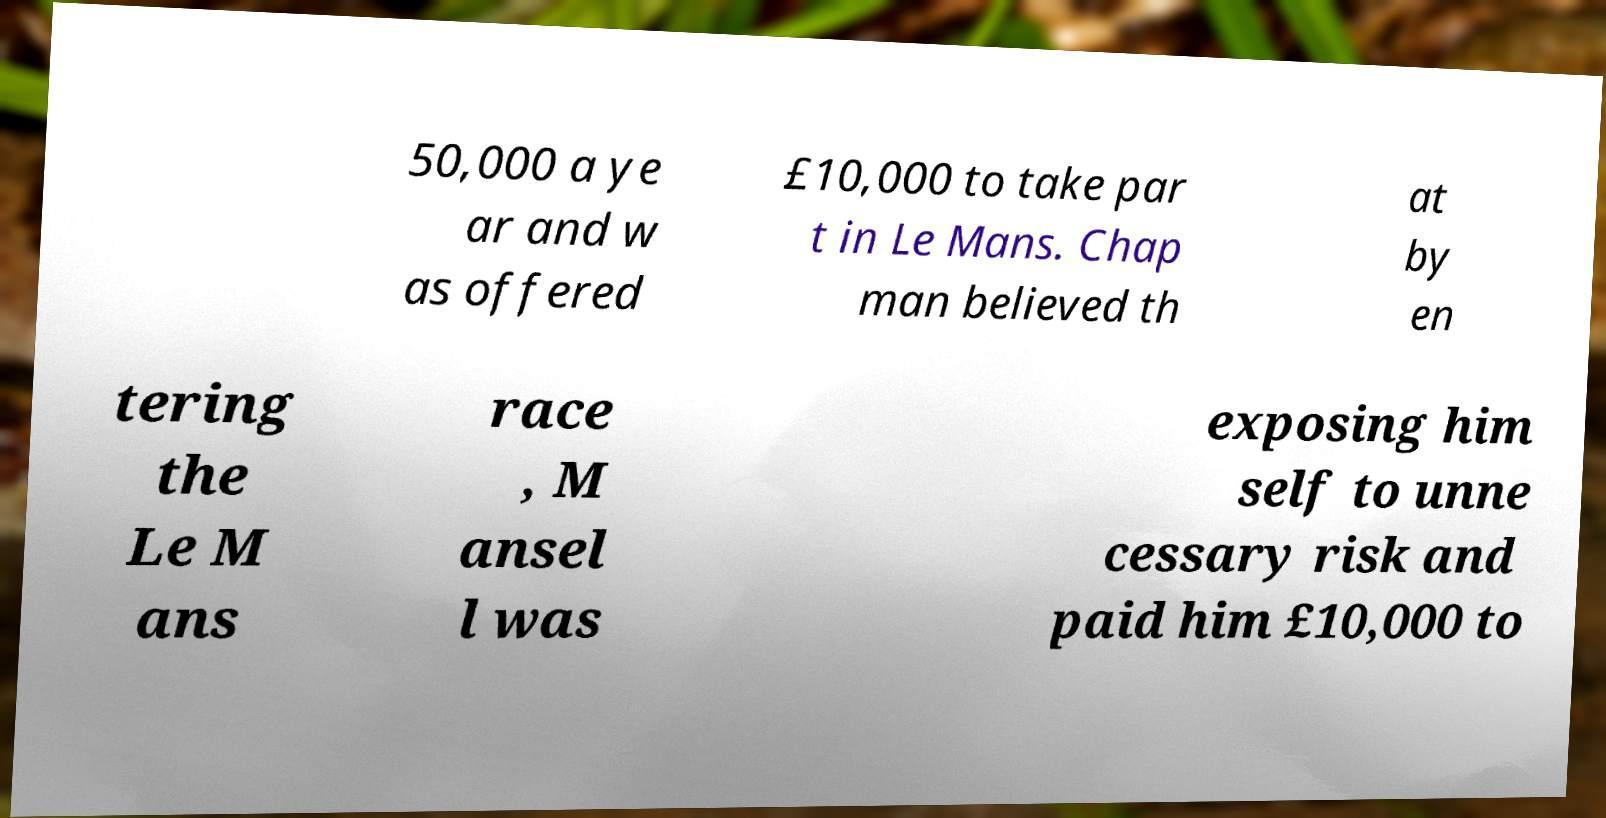What messages or text are displayed in this image? I need them in a readable, typed format. 50,000 a ye ar and w as offered £10,000 to take par t in Le Mans. Chap man believed th at by en tering the Le M ans race , M ansel l was exposing him self to unne cessary risk and paid him £10,000 to 